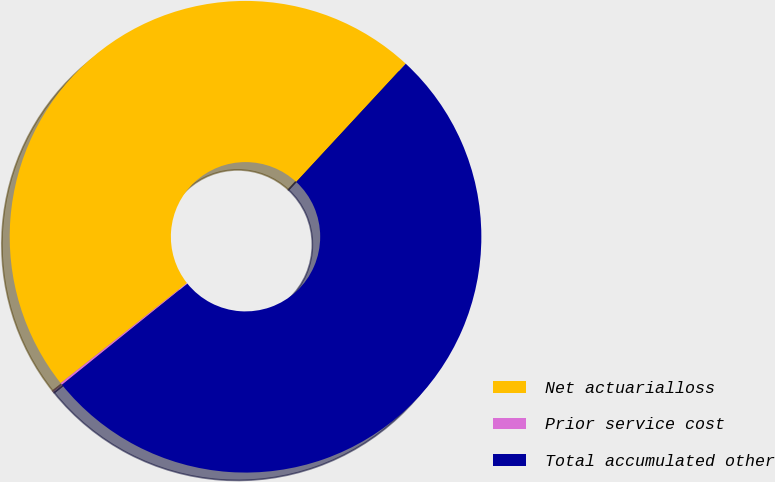Convert chart. <chart><loc_0><loc_0><loc_500><loc_500><pie_chart><fcel>Net actuarialloss<fcel>Prior service cost<fcel>Total accumulated other<nl><fcel>47.55%<fcel>0.14%<fcel>52.31%<nl></chart> 